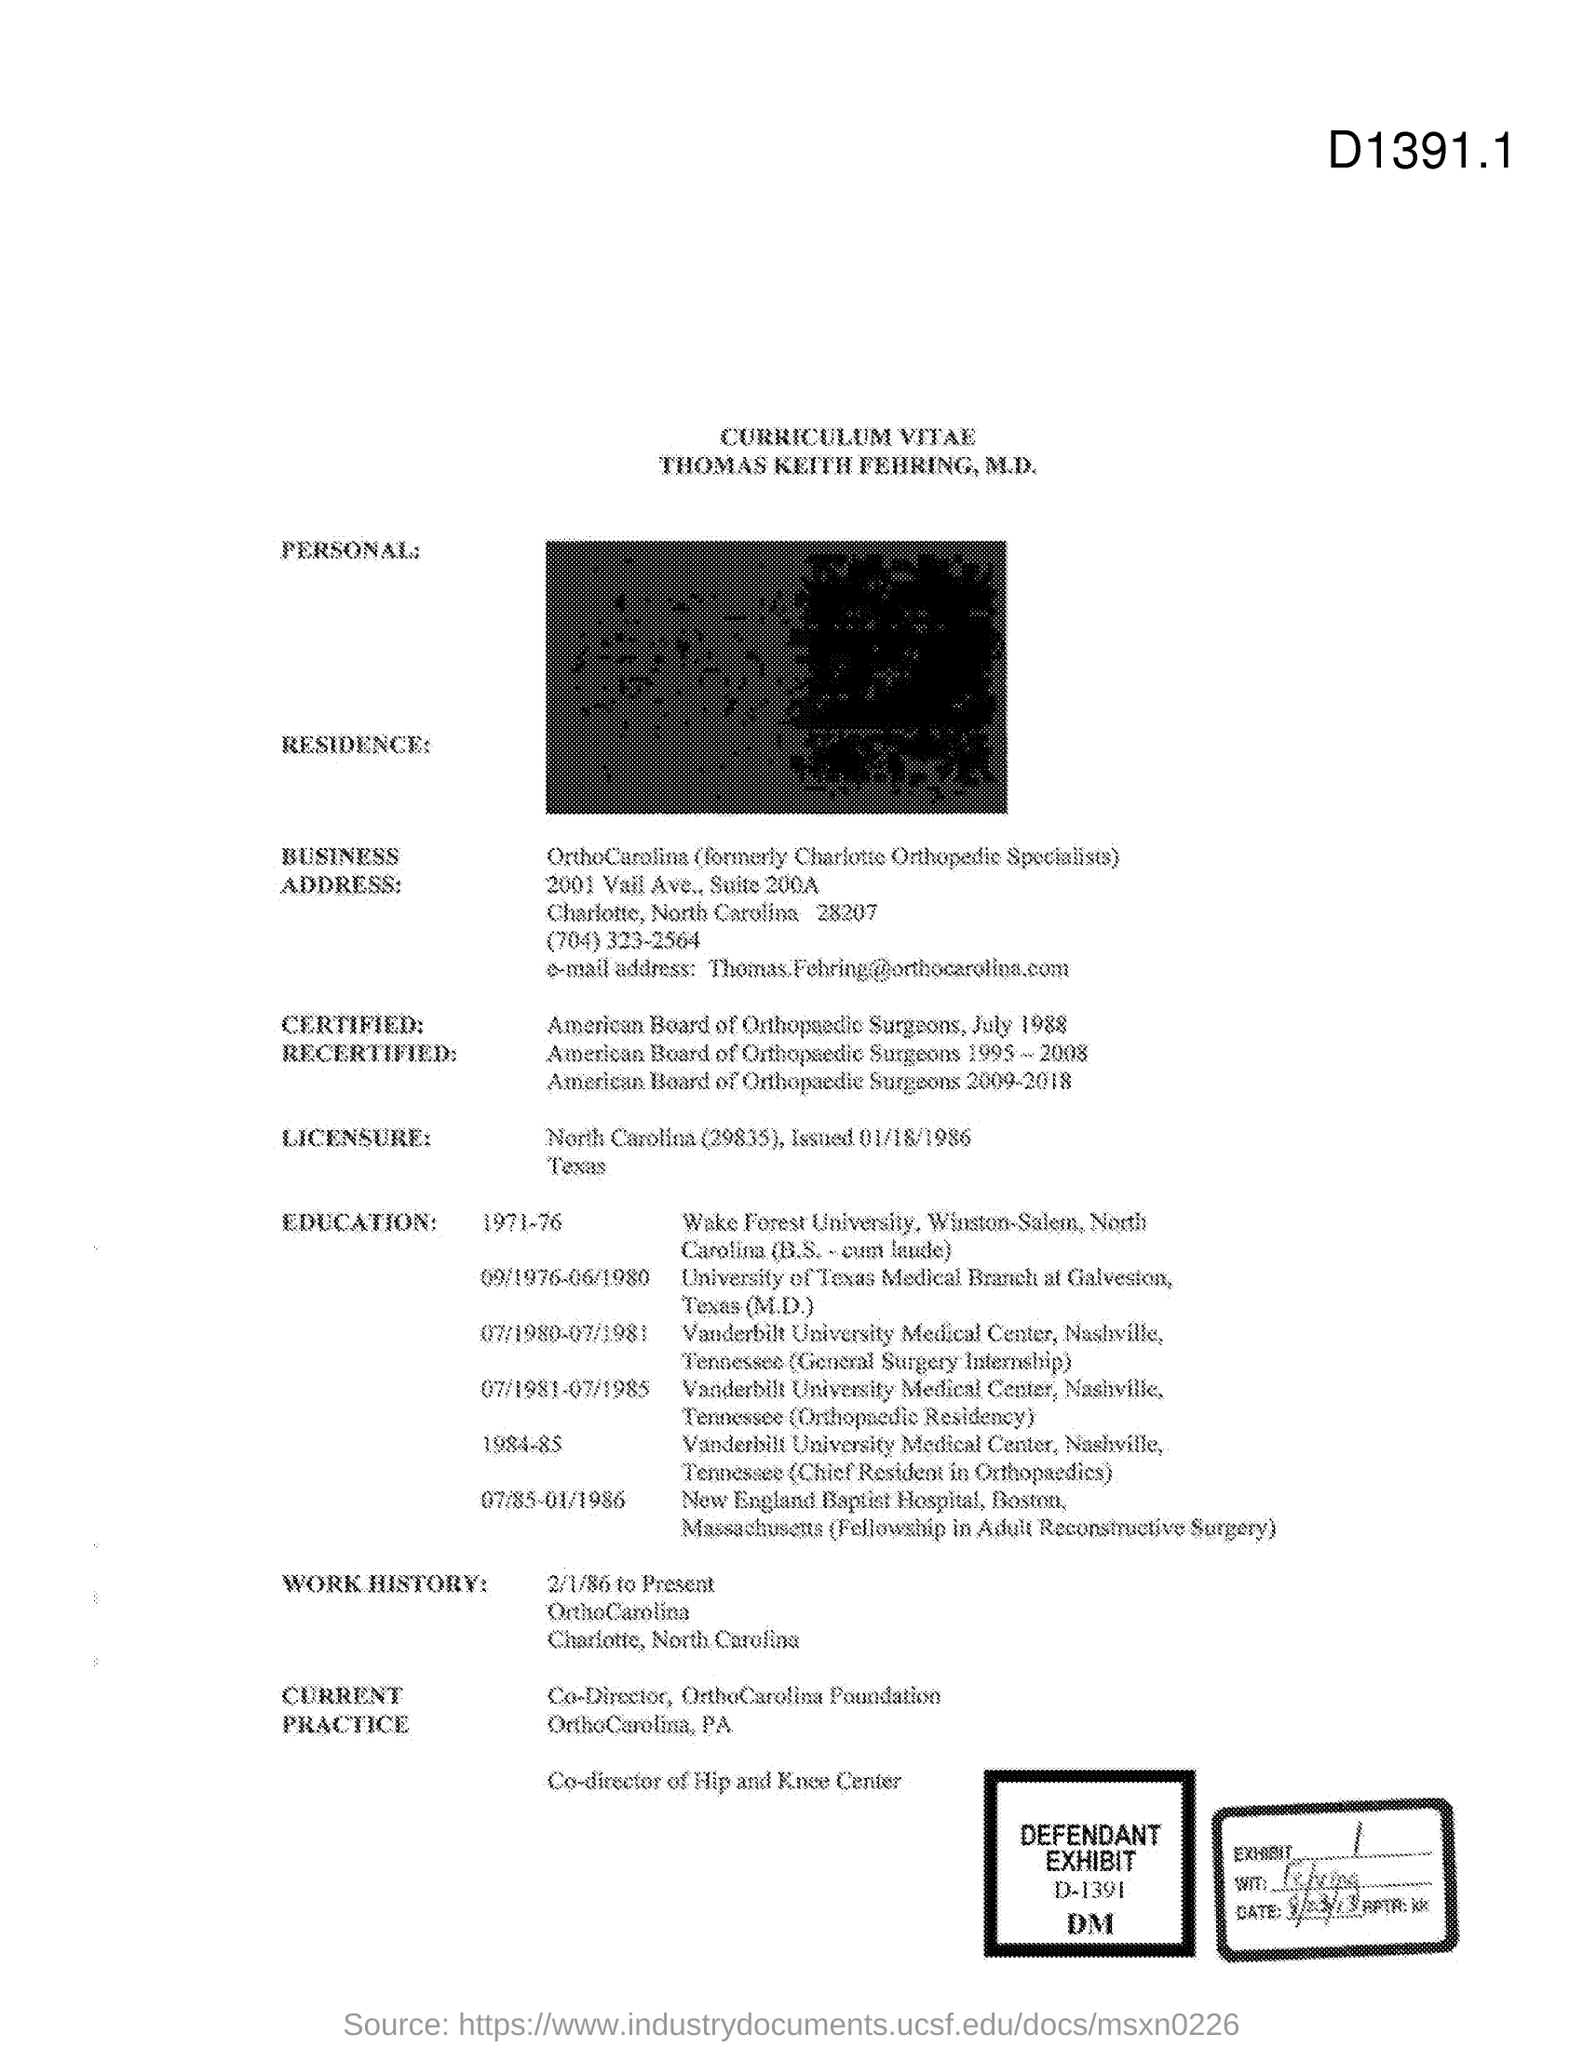Indicate a few pertinent items in this graphic. Exhibit number 1 is... What is the defendant's exhibit number? D-1391...," the witness declared. 